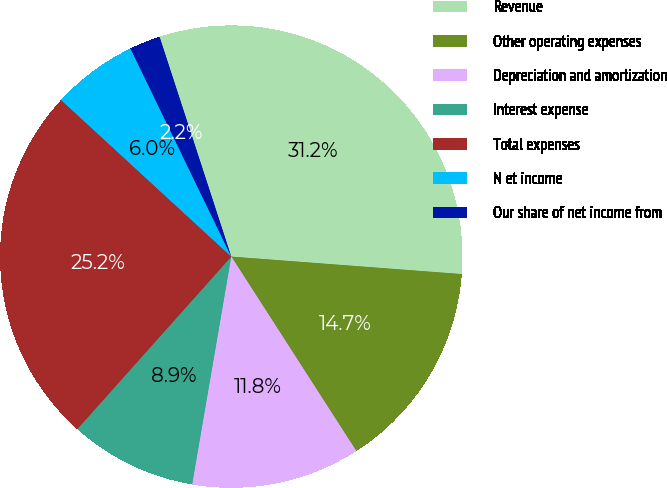Convert chart to OTSL. <chart><loc_0><loc_0><loc_500><loc_500><pie_chart><fcel>Revenue<fcel>Other operating expenses<fcel>Depreciation and amortization<fcel>Interest expense<fcel>Total expenses<fcel>N et income<fcel>Our share of net income from<nl><fcel>31.22%<fcel>14.7%<fcel>11.8%<fcel>8.89%<fcel>25.24%<fcel>5.98%<fcel>2.16%<nl></chart> 